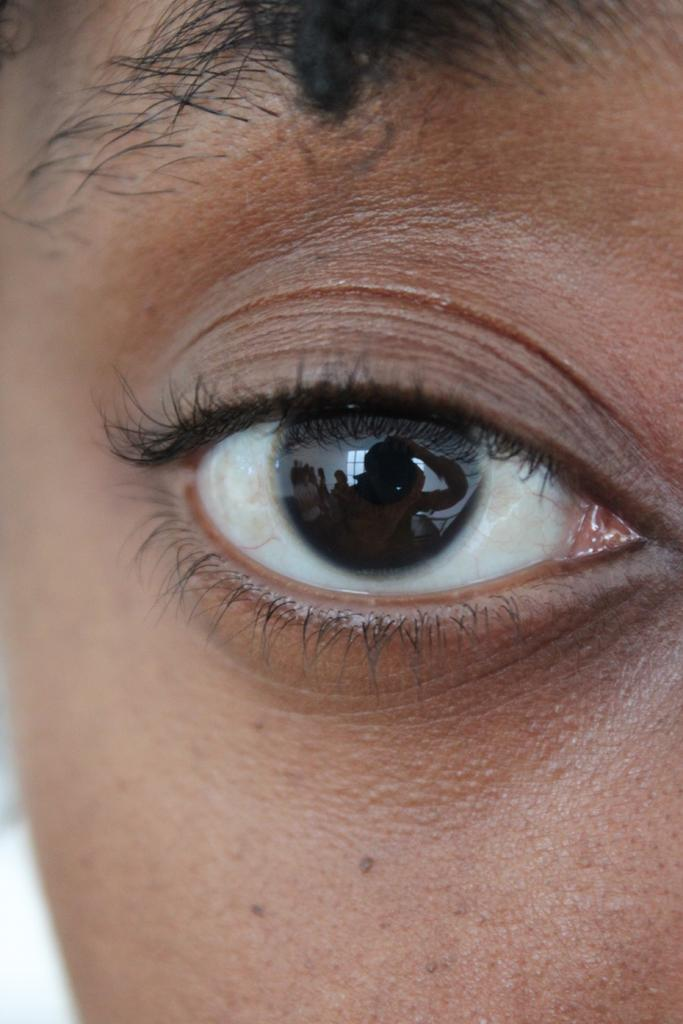What is the main subject of the image? The main subject of the image is a human eye. Are there any other facial features visible in the image? Yes, there are eyebrows at the top of the image. What type of word is written on the skin in the image? There are no words or text visible in the image, and the skin is not mentioned in the provided facts. 